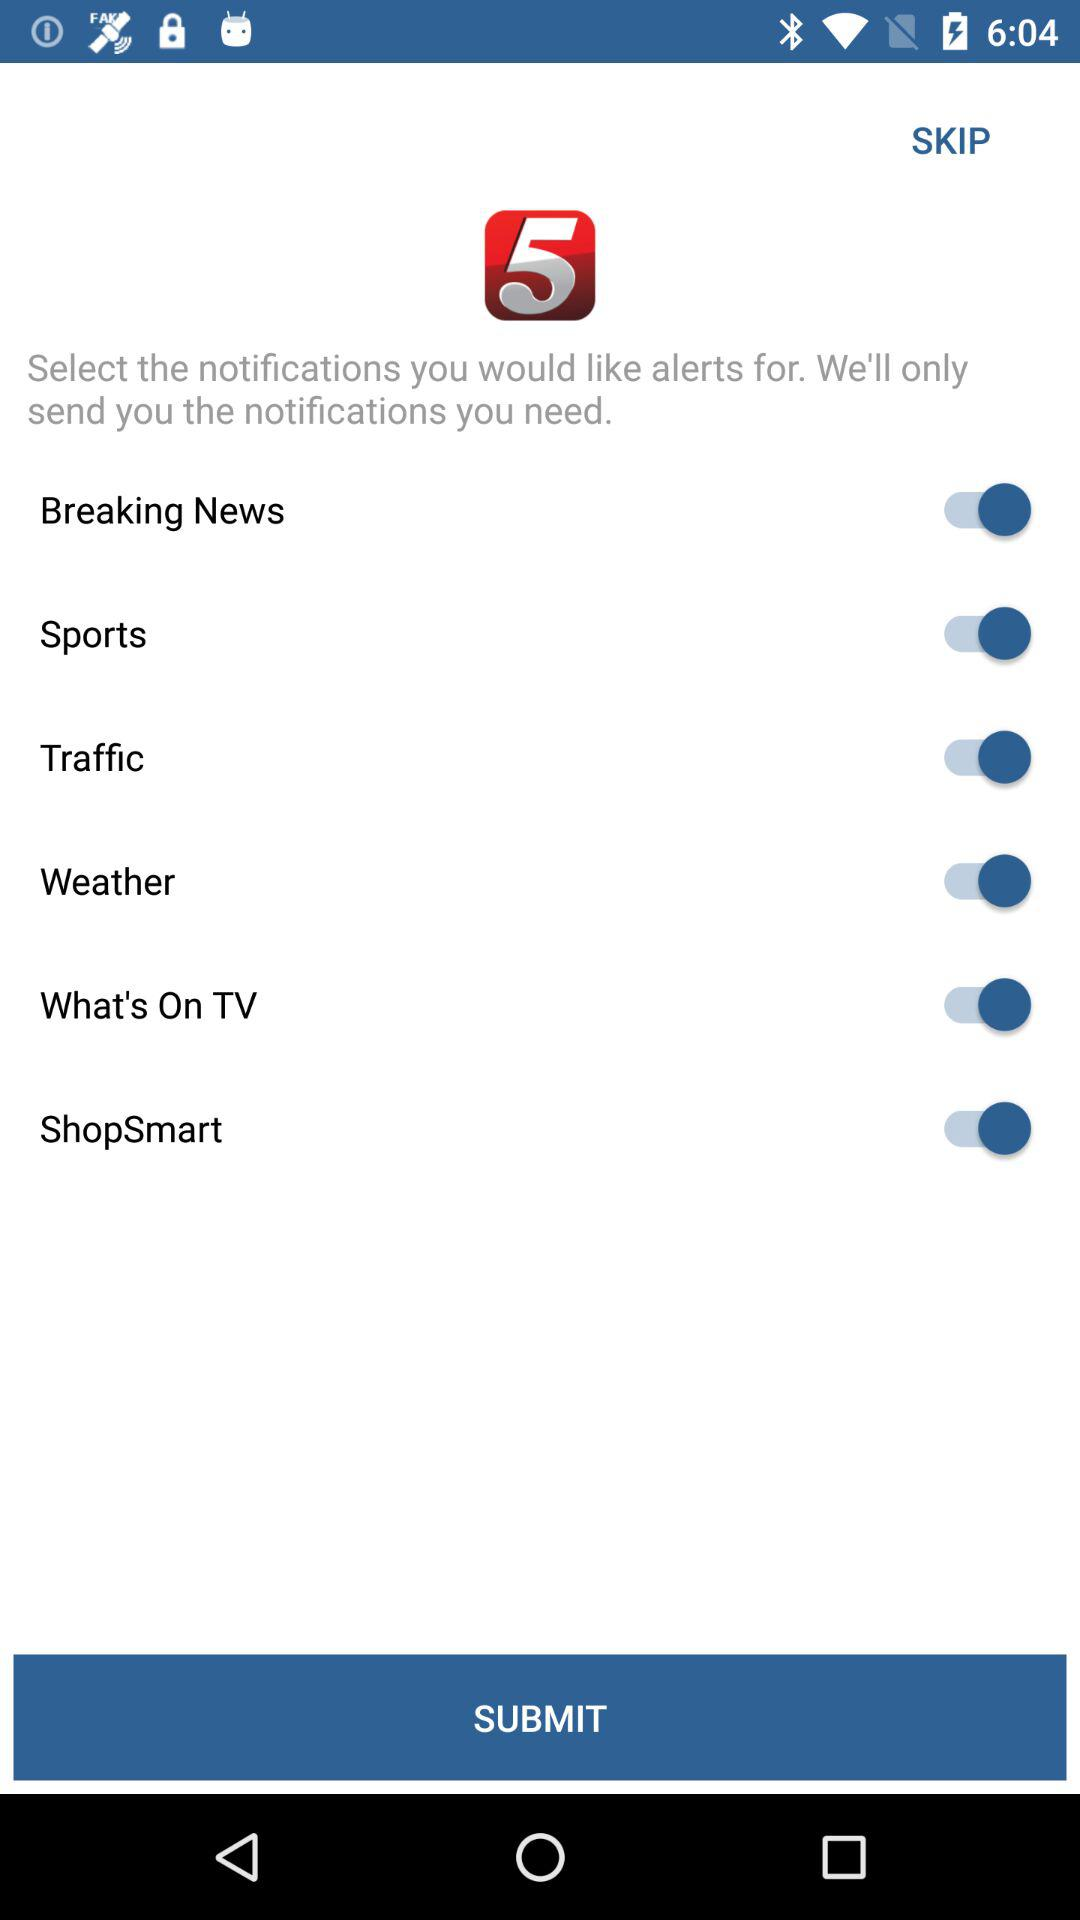How many notifications can I select?
Answer the question using a single word or phrase. 6 